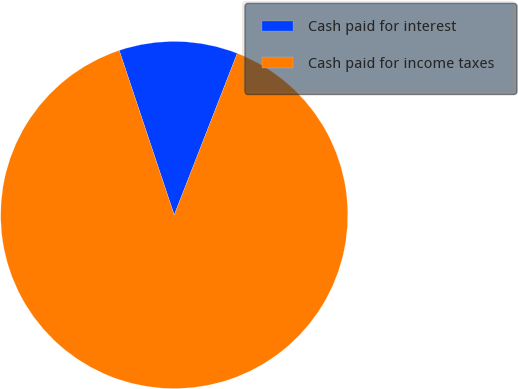<chart> <loc_0><loc_0><loc_500><loc_500><pie_chart><fcel>Cash paid for interest<fcel>Cash paid for income taxes<nl><fcel>11.05%<fcel>88.95%<nl></chart> 